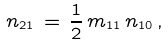<formula> <loc_0><loc_0><loc_500><loc_500>n _ { 2 1 } \, = \, \frac { 1 } { 2 } \, m _ { 1 1 } \, n _ { 1 0 } \, ,</formula> 